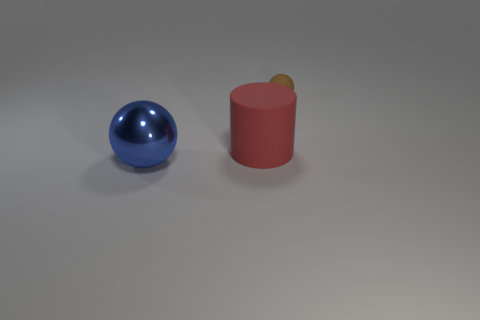How does the texture of the matte cylinder compare to the shiny metal sphere? The matte cylinder has a distinctly rougher and less reflective texture when compared to the shiny metal sphere. The sphere reflects light and surrounding colors, creating bright specular highlights, whereas the cylinder diffuses light, resulting in an even, non-reflective appearance. 